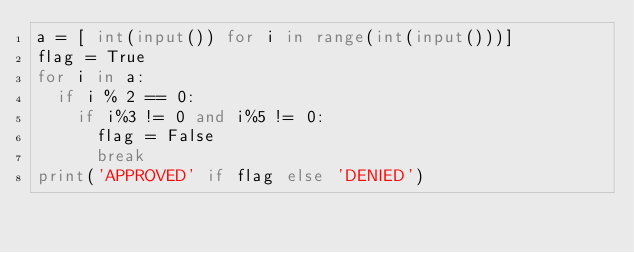Convert code to text. <code><loc_0><loc_0><loc_500><loc_500><_Python_>a = [ int(input()) for i in range(int(input()))]
flag = True
for i in a:
  if i % 2 == 0:
    if i%3 != 0 and i%5 != 0:
      flag = False
      break
print('APPROVED' if flag else 'DENIED')</code> 